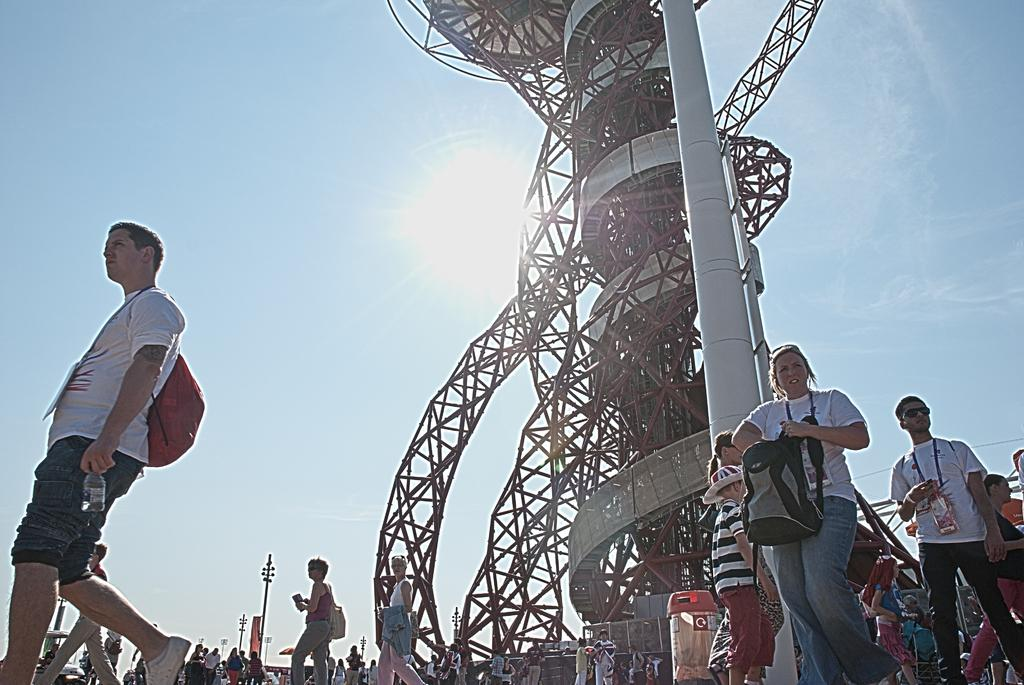What are the people in the image doing? The people in the image are walking on the road. What structure can be seen in the image? There is a tower in the image. What are the poles used for in the image? The purpose of the poles in the image is not specified, but they could be used for various purposes such as streetlights or signage. What else is visible in the image besides the people, tower, and poles? There are other objects visible in the image, but their specific details are not mentioned in the provided facts. What is the condition of the sky in the image? The sun is visible in the sky in the image, indicating that it is daytime. How many dimes are scattered on the road in the image? There are no dimes visible in the image; it only shows people walking on the road, a tower, poles, and other unspecified objects. 